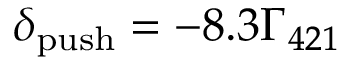Convert formula to latex. <formula><loc_0><loc_0><loc_500><loc_500>{ \delta _ { p u s h } } = - 8 . 3 { \Gamma _ { 4 2 1 } }</formula> 